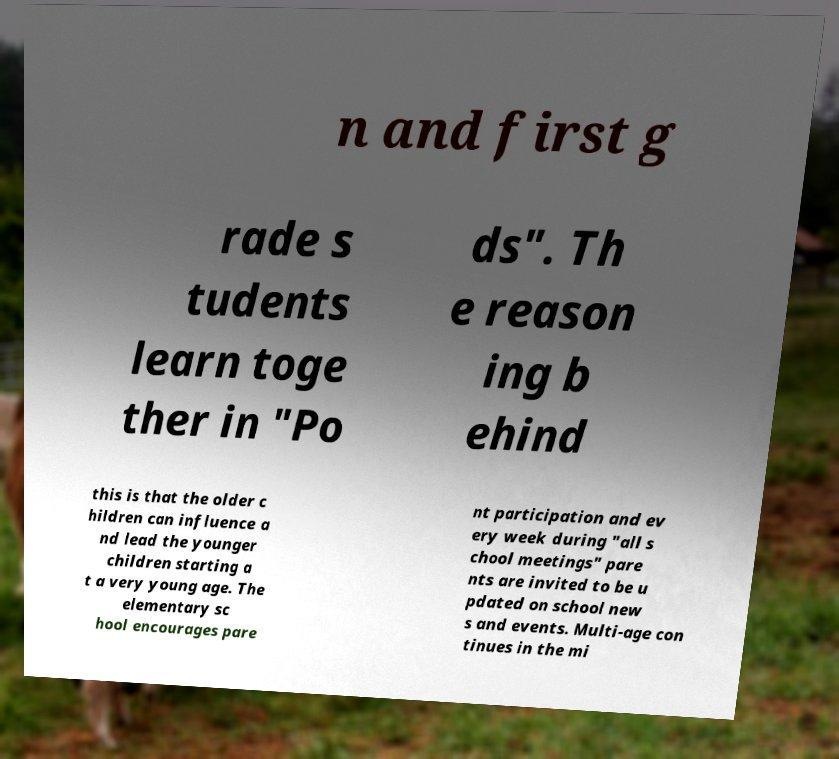For documentation purposes, I need the text within this image transcribed. Could you provide that? n and first g rade s tudents learn toge ther in "Po ds". Th e reason ing b ehind this is that the older c hildren can influence a nd lead the younger children starting a t a very young age. The elementary sc hool encourages pare nt participation and ev ery week during "all s chool meetings" pare nts are invited to be u pdated on school new s and events. Multi-age con tinues in the mi 